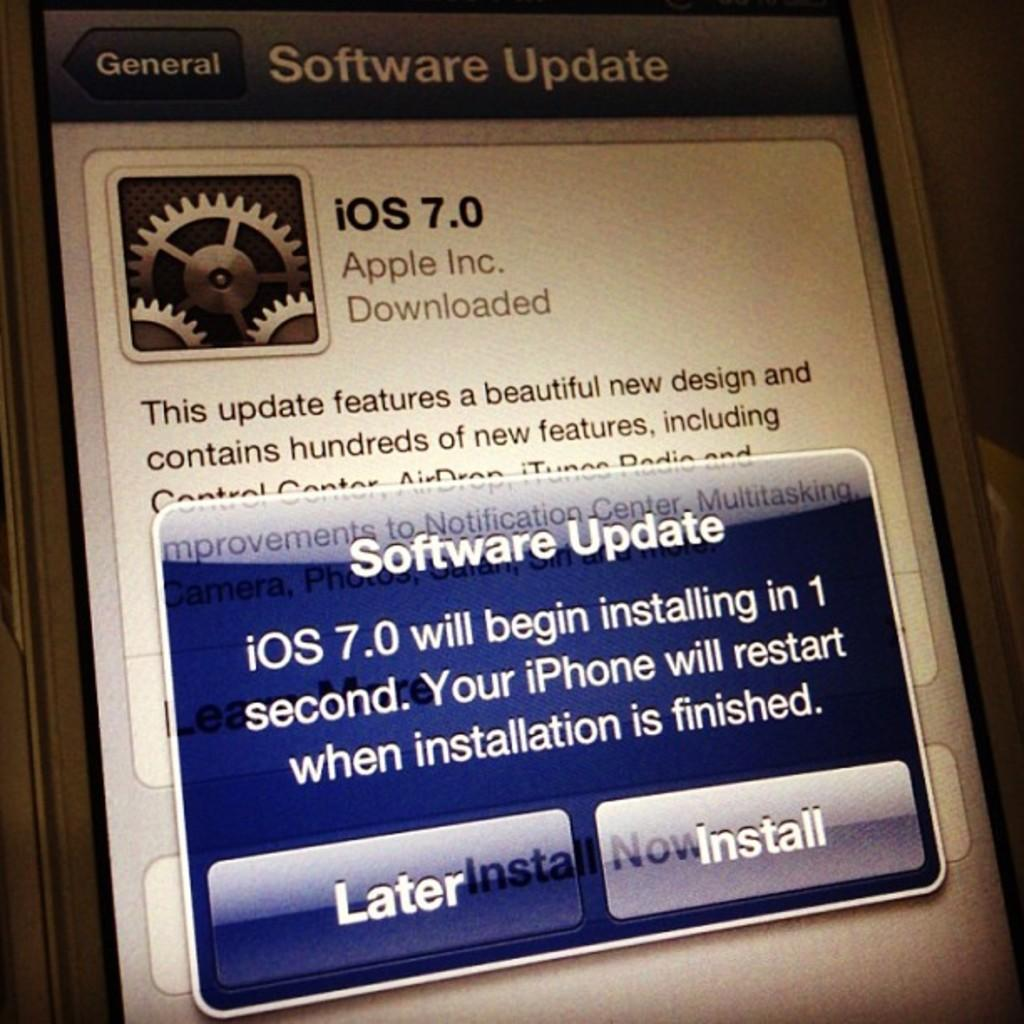<image>
Summarize the visual content of the image. A software update screen for a ios device. 